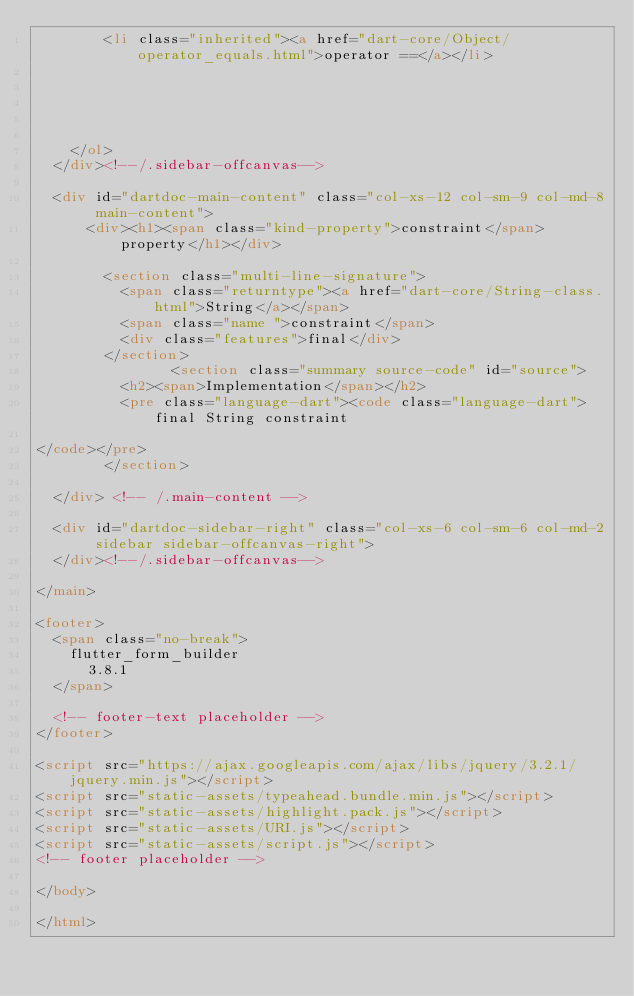<code> <loc_0><loc_0><loc_500><loc_500><_HTML_>        <li class="inherited"><a href="dart-core/Object/operator_equals.html">operator ==</a></li>
    
    
    
    
    
    </ol>
  </div><!--/.sidebar-offcanvas-->

  <div id="dartdoc-main-content" class="col-xs-12 col-sm-9 col-md-8 main-content">
      <div><h1><span class="kind-property">constraint</span> property</h1></div>

        <section class="multi-line-signature">
          <span class="returntype"><a href="dart-core/String-class.html">String</a></span>
          <span class="name ">constraint</span>
          <div class="features">final</div>
        </section>
                <section class="summary source-code" id="source">
          <h2><span>Implementation</span></h2>
          <pre class="language-dart"><code class="language-dart">final String constraint

</code></pre>
        </section>

  </div> <!-- /.main-content -->

  <div id="dartdoc-sidebar-right" class="col-xs-6 col-sm-6 col-md-2 sidebar sidebar-offcanvas-right">
  </div><!--/.sidebar-offcanvas-->

</main>

<footer>
  <span class="no-break">
    flutter_form_builder
      3.8.1
  </span>

  <!-- footer-text placeholder -->
</footer>

<script src="https://ajax.googleapis.com/ajax/libs/jquery/3.2.1/jquery.min.js"></script>
<script src="static-assets/typeahead.bundle.min.js"></script>
<script src="static-assets/highlight.pack.js"></script>
<script src="static-assets/URI.js"></script>
<script src="static-assets/script.js"></script>
<!-- footer placeholder -->

</body>

</html>
</code> 